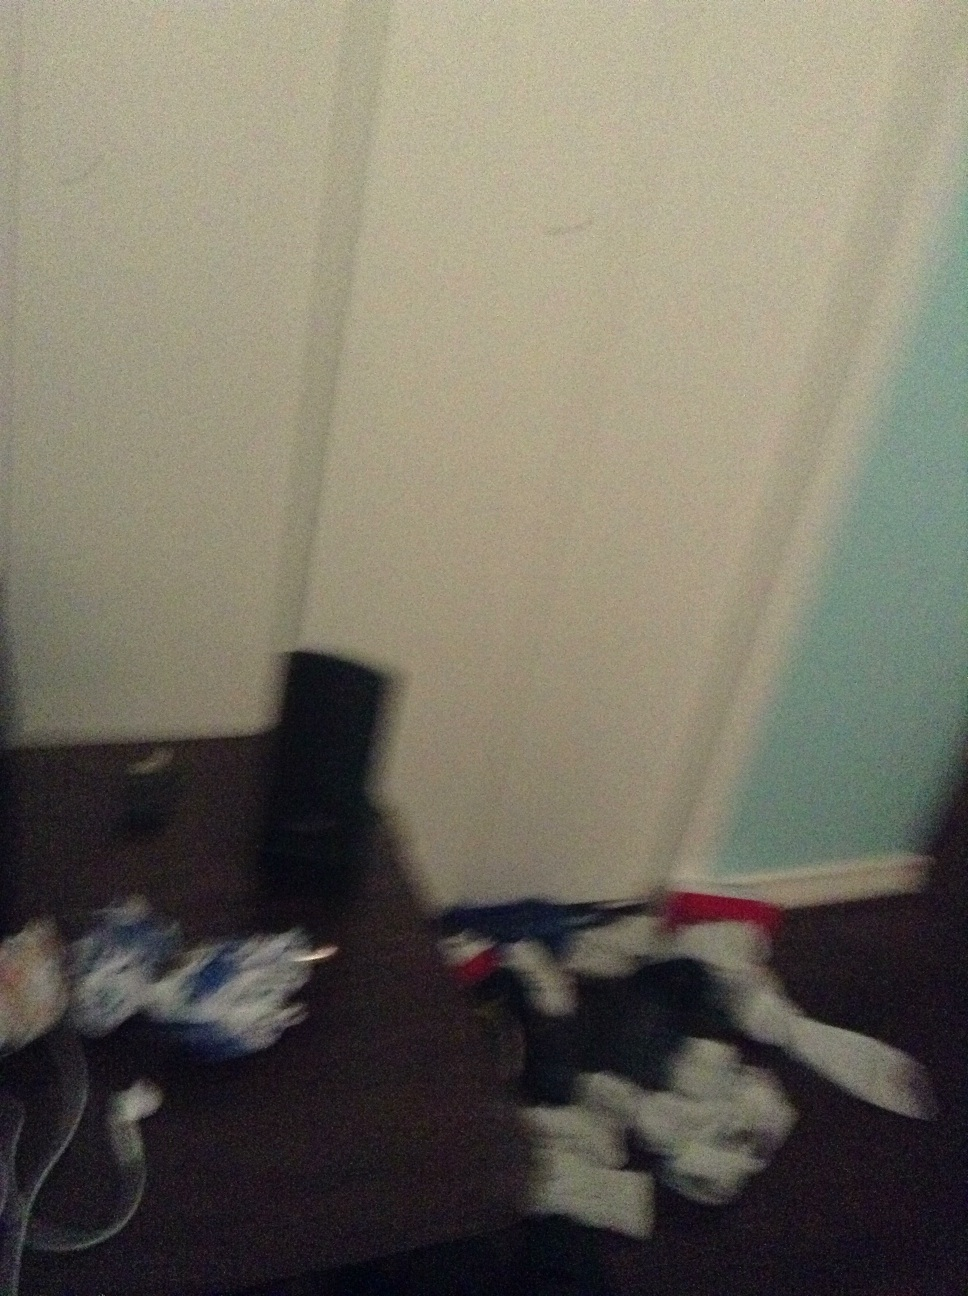Could the quality of the photo offer any clues about the situation in which it was taken? The low quality and blurry aspect of the photo suggest it was likely taken quickly or without an intent to focus properly. This could be indicative of a hurried action, perhaps in a casual or less-conscientious moment, like capturing an image to quickly remember the placement of items or during an unexpected situation. 